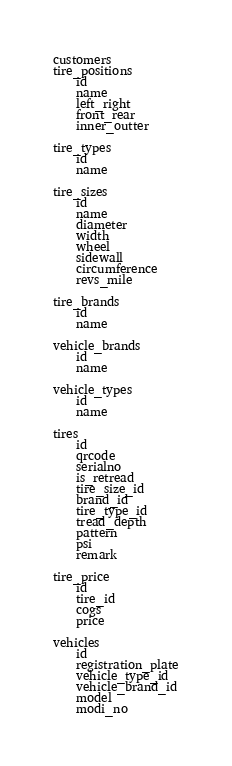<code> <loc_0><loc_0><loc_500><loc_500><_SQL_>customers
tire_positions
    id
    name
    left_right
    front_rear
    inner_outter

tire_types
    id
    name

tire_sizes
    id
    name
    diameter
    width
    wheel
    sidewall
    circumference
    revs_mile
    
tire_brands
    id
    name

vehicle_brands
    id
    name

vehicle_types
    id
    name

tires
    id
    qrcode
    serialno
    is_retread
    tire_size_id
    brand_id
    tire_type_id
    tread_depth
    pattern
    psi
    remark

tire_price
    id
    tire_id
    cogs
    price

vehicles
    id
    registration_plate
    vehicle_type_id
    vehicle_brand_id
    model
    modi_no</code> 